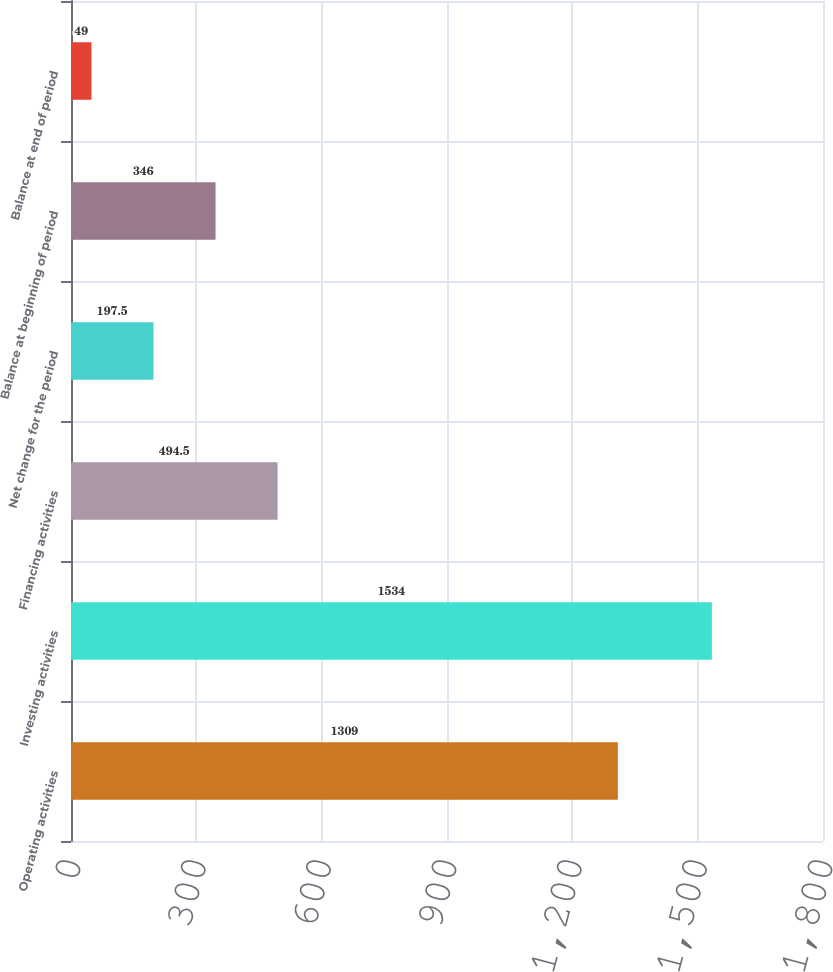Convert chart to OTSL. <chart><loc_0><loc_0><loc_500><loc_500><bar_chart><fcel>Operating activities<fcel>Investing activities<fcel>Financing activities<fcel>Net change for the period<fcel>Balance at beginning of period<fcel>Balance at end of period<nl><fcel>1309<fcel>1534<fcel>494.5<fcel>197.5<fcel>346<fcel>49<nl></chart> 